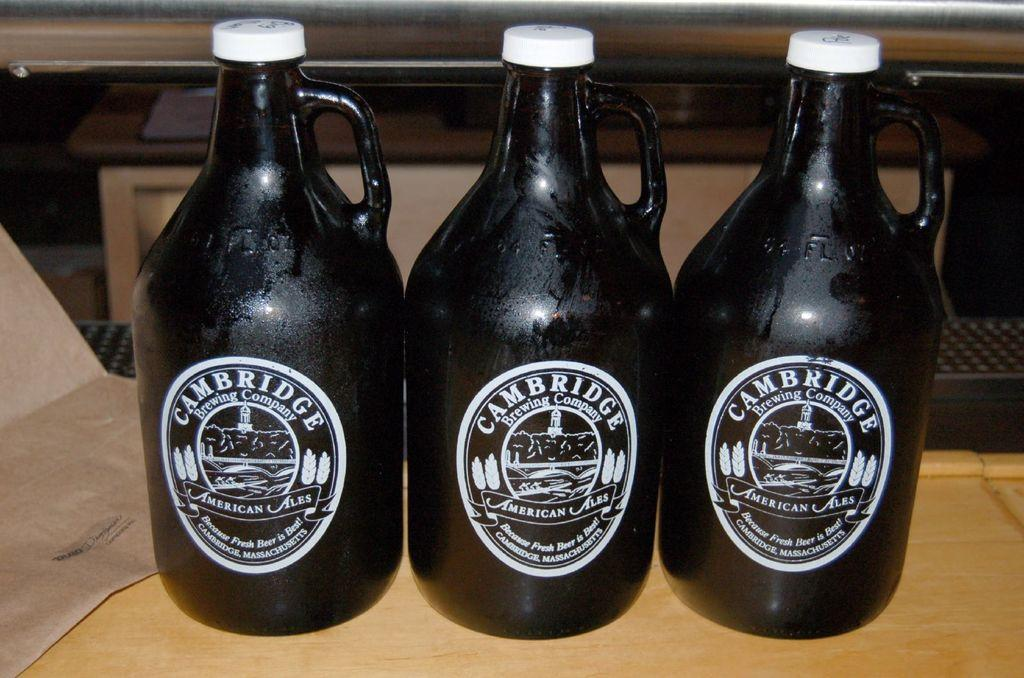<image>
Render a clear and concise summary of the photo. Three ornate bottles of Cambridge Ale stand side by side. 